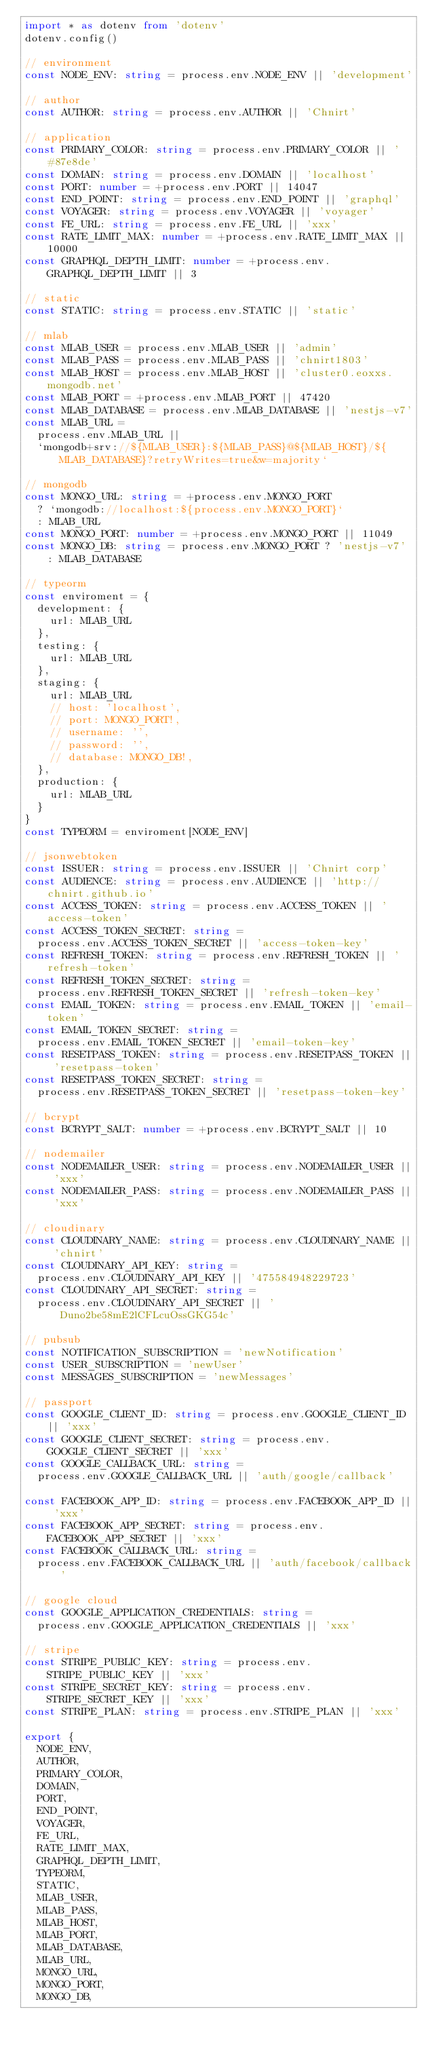<code> <loc_0><loc_0><loc_500><loc_500><_TypeScript_>import * as dotenv from 'dotenv'
dotenv.config()

// environment
const NODE_ENV: string = process.env.NODE_ENV || 'development'

// author
const AUTHOR: string = process.env.AUTHOR || 'Chnirt'

// application
const PRIMARY_COLOR: string = process.env.PRIMARY_COLOR || '#87e8de'
const DOMAIN: string = process.env.DOMAIN || 'localhost'
const PORT: number = +process.env.PORT || 14047
const END_POINT: string = process.env.END_POINT || 'graphql'
const VOYAGER: string = process.env.VOYAGER || 'voyager'
const FE_URL: string = process.env.FE_URL || 'xxx'
const RATE_LIMIT_MAX: number = +process.env.RATE_LIMIT_MAX || 10000
const GRAPHQL_DEPTH_LIMIT: number = +process.env.GRAPHQL_DEPTH_LIMIT || 3

// static
const STATIC: string = process.env.STATIC || 'static'

// mlab
const MLAB_USER = process.env.MLAB_USER || 'admin'
const MLAB_PASS = process.env.MLAB_PASS || 'chnirt1803'
const MLAB_HOST = process.env.MLAB_HOST || 'cluster0.eoxxs.mongodb.net'
const MLAB_PORT = +process.env.MLAB_PORT || 47420
const MLAB_DATABASE = process.env.MLAB_DATABASE || 'nestjs-v7'
const MLAB_URL =
	process.env.MLAB_URL ||
	`mongodb+srv://${MLAB_USER}:${MLAB_PASS}@${MLAB_HOST}/${MLAB_DATABASE}?retryWrites=true&w=majority`

// mongodb
const MONGO_URL: string = +process.env.MONGO_PORT
	? `mongodb://localhost:${process.env.MONGO_PORT}`
	: MLAB_URL
const MONGO_PORT: number = +process.env.MONGO_PORT || 11049
const MONGO_DB: string = process.env.MONGO_PORT ? 'nestjs-v7' : MLAB_DATABASE

// typeorm
const enviroment = {
	development: {
		url: MLAB_URL
	},
	testing: {
		url: MLAB_URL
	},
	staging: {
		url: MLAB_URL
		// host: 'localhost',
		// port: MONGO_PORT!,
		// username: '',
		// password: '',
		// database: MONGO_DB!,
	},
	production: {
		url: MLAB_URL
	}
}
const TYPEORM = enviroment[NODE_ENV]

// jsonwebtoken
const ISSUER: string = process.env.ISSUER || 'Chnirt corp'
const AUDIENCE: string = process.env.AUDIENCE || 'http://chnirt.github.io'
const ACCESS_TOKEN: string = process.env.ACCESS_TOKEN || 'access-token'
const ACCESS_TOKEN_SECRET: string =
	process.env.ACCESS_TOKEN_SECRET || 'access-token-key'
const REFRESH_TOKEN: string = process.env.REFRESH_TOKEN || 'refresh-token'
const REFRESH_TOKEN_SECRET: string =
	process.env.REFRESH_TOKEN_SECRET || 'refresh-token-key'
const EMAIL_TOKEN: string = process.env.EMAIL_TOKEN || 'email-token'
const EMAIL_TOKEN_SECRET: string =
	process.env.EMAIL_TOKEN_SECRET || 'email-token-key'
const RESETPASS_TOKEN: string = process.env.RESETPASS_TOKEN || 'resetpass-token'
const RESETPASS_TOKEN_SECRET: string =
	process.env.RESETPASS_TOKEN_SECRET || 'resetpass-token-key'

// bcrypt
const BCRYPT_SALT: number = +process.env.BCRYPT_SALT || 10

// nodemailer
const NODEMAILER_USER: string = process.env.NODEMAILER_USER || 'xxx'
const NODEMAILER_PASS: string = process.env.NODEMAILER_PASS || 'xxx'

// cloudinary
const CLOUDINARY_NAME: string = process.env.CLOUDINARY_NAME || 'chnirt'
const CLOUDINARY_API_KEY: string =
	process.env.CLOUDINARY_API_KEY || '475584948229723'
const CLOUDINARY_API_SECRET: string =
	process.env.CLOUDINARY_API_SECRET || 'Duno2be58mE2lCFLcuOssGKG54c'

// pubsub
const NOTIFICATION_SUBSCRIPTION = 'newNotification'
const USER_SUBSCRIPTION = 'newUser'
const MESSAGES_SUBSCRIPTION = 'newMessages'

// passport
const GOOGLE_CLIENT_ID: string = process.env.GOOGLE_CLIENT_ID || 'xxx'
const GOOGLE_CLIENT_SECRET: string = process.env.GOOGLE_CLIENT_SECRET || 'xxx'
const GOOGLE_CALLBACK_URL: string =
	process.env.GOOGLE_CALLBACK_URL || 'auth/google/callback'

const FACEBOOK_APP_ID: string = process.env.FACEBOOK_APP_ID || 'xxx'
const FACEBOOK_APP_SECRET: string = process.env.FACEBOOK_APP_SECRET || 'xxx'
const FACEBOOK_CALLBACK_URL: string =
	process.env.FACEBOOK_CALLBACK_URL || 'auth/facebook/callback'

// google cloud
const GOOGLE_APPLICATION_CREDENTIALS: string =
	process.env.GOOGLE_APPLICATION_CREDENTIALS || 'xxx'

// stripe
const STRIPE_PUBLIC_KEY: string = process.env.STRIPE_PUBLIC_KEY || 'xxx'
const STRIPE_SECRET_KEY: string = process.env.STRIPE_SECRET_KEY || 'xxx'
const STRIPE_PLAN: string = process.env.STRIPE_PLAN || 'xxx'

export {
	NODE_ENV,
	AUTHOR,
	PRIMARY_COLOR,
	DOMAIN,
	PORT,
	END_POINT,
	VOYAGER,
	FE_URL,
	RATE_LIMIT_MAX,
	GRAPHQL_DEPTH_LIMIT,
	TYPEORM,
	STATIC,
	MLAB_USER,
	MLAB_PASS,
	MLAB_HOST,
	MLAB_PORT,
	MLAB_DATABASE,
	MLAB_URL,
	MONGO_URL,
	MONGO_PORT,
	MONGO_DB,</code> 